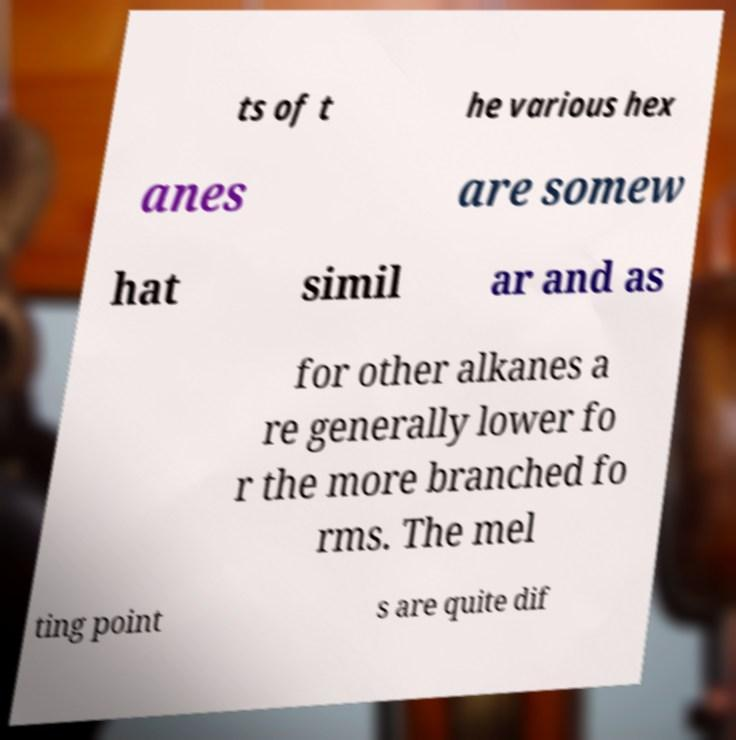What messages or text are displayed in this image? I need them in a readable, typed format. ts of t he various hex anes are somew hat simil ar and as for other alkanes a re generally lower fo r the more branched fo rms. The mel ting point s are quite dif 